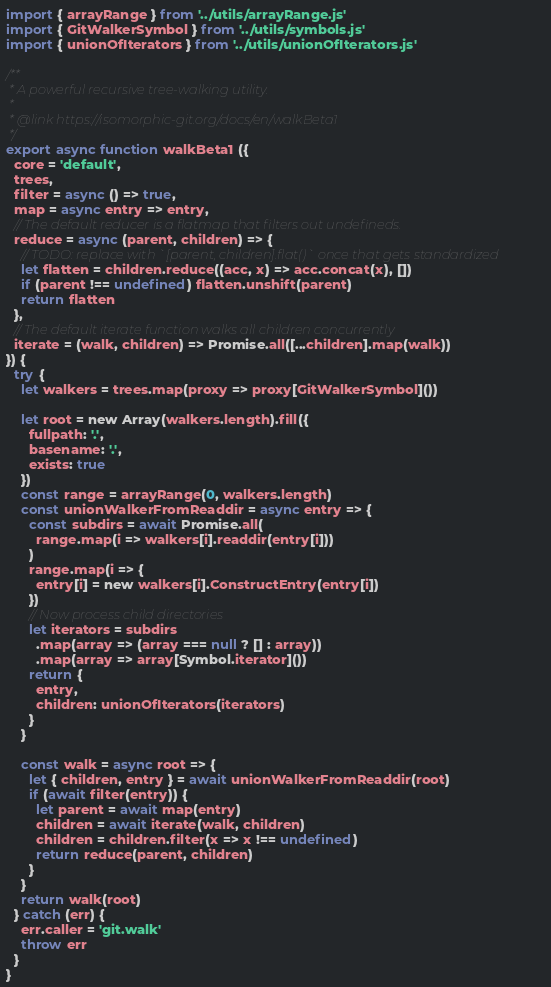Convert code to text. <code><loc_0><loc_0><loc_500><loc_500><_JavaScript_>import { arrayRange } from '../utils/arrayRange.js'
import { GitWalkerSymbol } from '../utils/symbols.js'
import { unionOfIterators } from '../utils/unionOfIterators.js'

/**
 * A powerful recursive tree-walking utility.
 *
 * @link https://isomorphic-git.org/docs/en/walkBeta1
 */
export async function walkBeta1 ({
  core = 'default',
  trees,
  filter = async () => true,
  map = async entry => entry,
  // The default reducer is a flatmap that filters out undefineds.
  reduce = async (parent, children) => {
    // TODO: replace with `[parent, children].flat()` once that gets standardized
    let flatten = children.reduce((acc, x) => acc.concat(x), [])
    if (parent !== undefined) flatten.unshift(parent)
    return flatten
  },
  // The default iterate function walks all children concurrently
  iterate = (walk, children) => Promise.all([...children].map(walk))
}) {
  try {
    let walkers = trees.map(proxy => proxy[GitWalkerSymbol]())

    let root = new Array(walkers.length).fill({
      fullpath: '.',
      basename: '.',
      exists: true
    })
    const range = arrayRange(0, walkers.length)
    const unionWalkerFromReaddir = async entry => {
      const subdirs = await Promise.all(
        range.map(i => walkers[i].readdir(entry[i]))
      )
      range.map(i => {
        entry[i] = new walkers[i].ConstructEntry(entry[i])
      })
      // Now process child directories
      let iterators = subdirs
        .map(array => (array === null ? [] : array))
        .map(array => array[Symbol.iterator]())
      return {
        entry,
        children: unionOfIterators(iterators)
      }
    }

    const walk = async root => {
      let { children, entry } = await unionWalkerFromReaddir(root)
      if (await filter(entry)) {
        let parent = await map(entry)
        children = await iterate(walk, children)
        children = children.filter(x => x !== undefined)
        return reduce(parent, children)
      }
    }
    return walk(root)
  } catch (err) {
    err.caller = 'git.walk'
    throw err
  }
}
</code> 